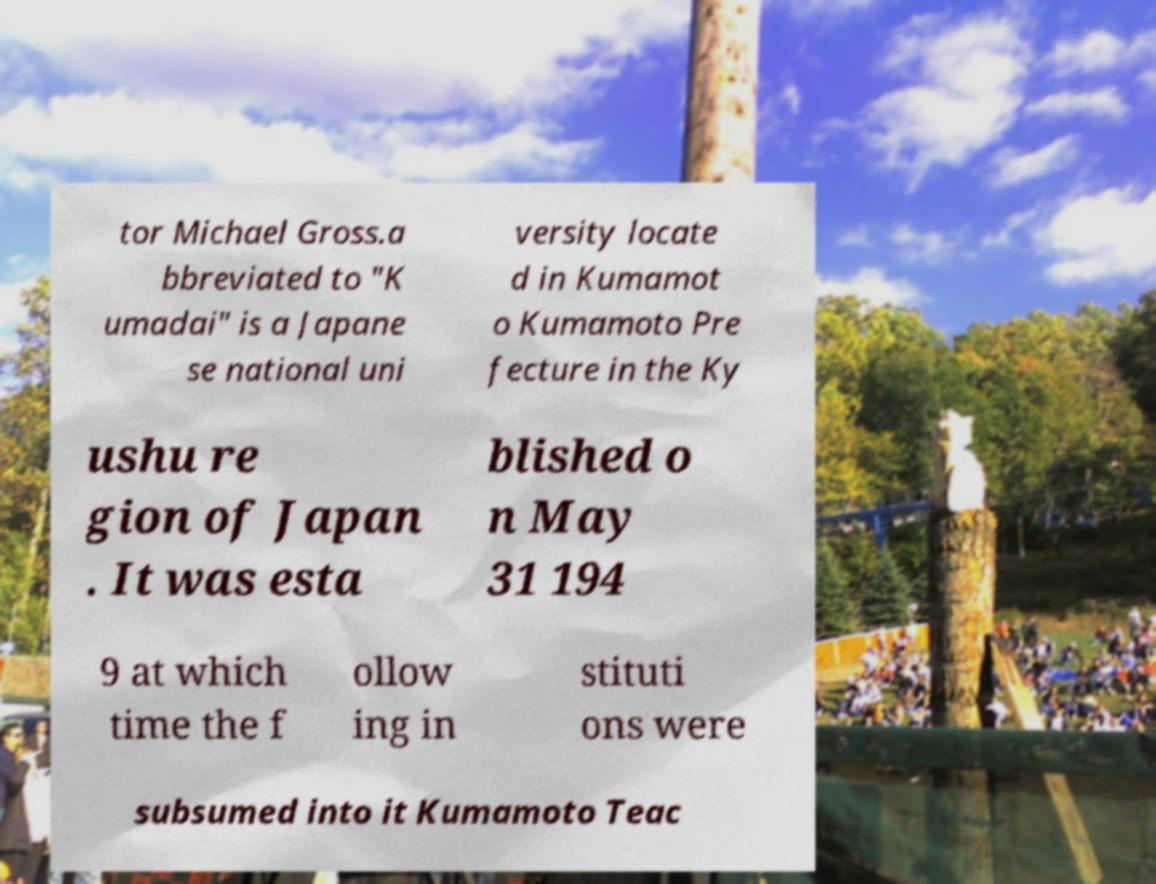Can you read and provide the text displayed in the image?This photo seems to have some interesting text. Can you extract and type it out for me? tor Michael Gross.a bbreviated to "K umadai" is a Japane se national uni versity locate d in Kumamot o Kumamoto Pre fecture in the Ky ushu re gion of Japan . It was esta blished o n May 31 194 9 at which time the f ollow ing in stituti ons were subsumed into it Kumamoto Teac 